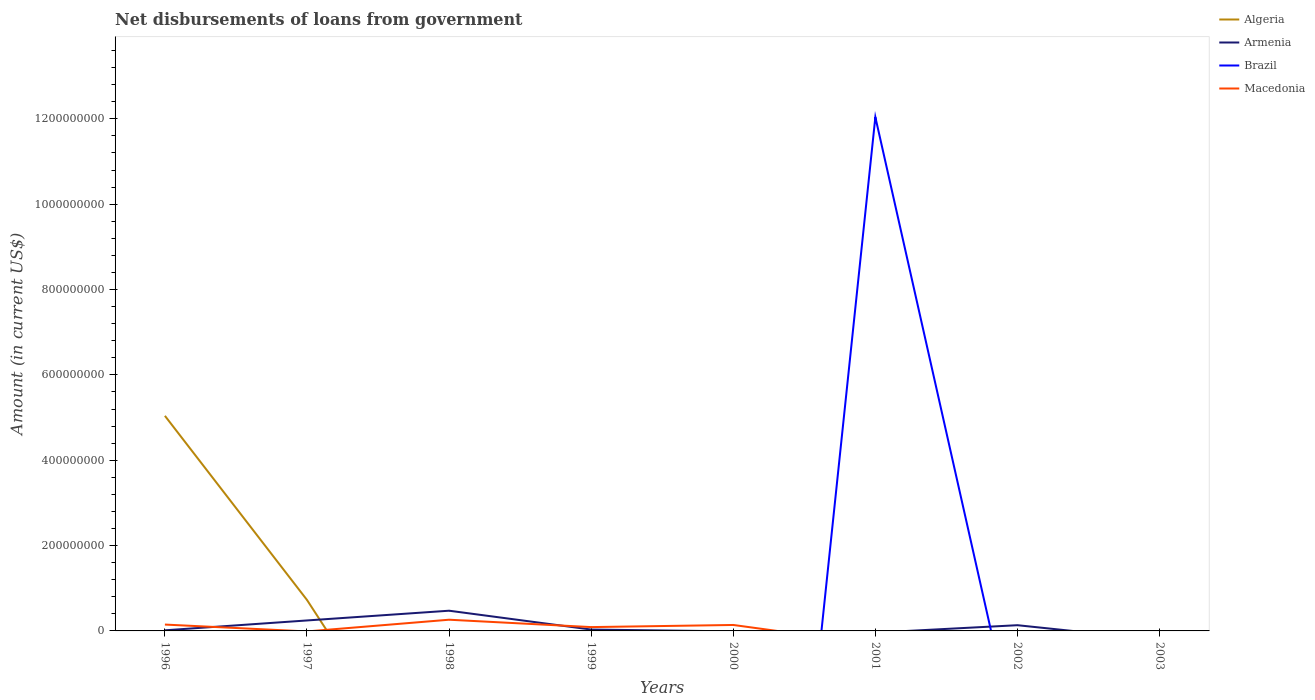How many different coloured lines are there?
Offer a terse response. 4. Does the line corresponding to Brazil intersect with the line corresponding to Macedonia?
Offer a terse response. Yes. Is the number of lines equal to the number of legend labels?
Offer a terse response. No. Across all years, what is the maximum amount of loan disbursed from government in Macedonia?
Provide a short and direct response. 0. What is the total amount of loan disbursed from government in Armenia in the graph?
Offer a very short reply. 1.11e+07. What is the difference between the highest and the second highest amount of loan disbursed from government in Armenia?
Provide a short and direct response. 4.74e+07. Is the amount of loan disbursed from government in Algeria strictly greater than the amount of loan disbursed from government in Macedonia over the years?
Offer a very short reply. No. How many lines are there?
Offer a terse response. 4. How many years are there in the graph?
Your answer should be compact. 8. Are the values on the major ticks of Y-axis written in scientific E-notation?
Provide a succinct answer. No. How many legend labels are there?
Your response must be concise. 4. How are the legend labels stacked?
Your response must be concise. Vertical. What is the title of the graph?
Provide a succinct answer. Net disbursements of loans from government. What is the label or title of the X-axis?
Give a very brief answer. Years. What is the Amount (in current US$) in Algeria in 1996?
Your answer should be very brief. 5.04e+08. What is the Amount (in current US$) in Armenia in 1996?
Your answer should be compact. 1.45e+06. What is the Amount (in current US$) of Macedonia in 1996?
Offer a terse response. 1.49e+07. What is the Amount (in current US$) in Algeria in 1997?
Your answer should be very brief. 7.26e+07. What is the Amount (in current US$) in Armenia in 1997?
Provide a short and direct response. 2.45e+07. What is the Amount (in current US$) in Macedonia in 1997?
Keep it short and to the point. 0. What is the Amount (in current US$) in Algeria in 1998?
Make the answer very short. 0. What is the Amount (in current US$) of Armenia in 1998?
Provide a succinct answer. 4.74e+07. What is the Amount (in current US$) in Macedonia in 1998?
Provide a short and direct response. 2.63e+07. What is the Amount (in current US$) of Armenia in 1999?
Offer a very short reply. 3.22e+06. What is the Amount (in current US$) of Brazil in 1999?
Your answer should be very brief. 0. What is the Amount (in current US$) in Macedonia in 1999?
Offer a terse response. 8.96e+06. What is the Amount (in current US$) of Algeria in 2000?
Your answer should be very brief. 0. What is the Amount (in current US$) in Macedonia in 2000?
Your answer should be compact. 1.40e+07. What is the Amount (in current US$) in Algeria in 2001?
Provide a short and direct response. 0. What is the Amount (in current US$) of Armenia in 2001?
Give a very brief answer. 0. What is the Amount (in current US$) in Brazil in 2001?
Your answer should be very brief. 1.20e+09. What is the Amount (in current US$) of Algeria in 2002?
Your answer should be very brief. 0. What is the Amount (in current US$) of Armenia in 2002?
Your response must be concise. 1.34e+07. What is the Amount (in current US$) in Macedonia in 2002?
Your response must be concise. 0. What is the Amount (in current US$) of Armenia in 2003?
Ensure brevity in your answer.  0. What is the Amount (in current US$) in Macedonia in 2003?
Your answer should be very brief. 0. Across all years, what is the maximum Amount (in current US$) in Algeria?
Offer a terse response. 5.04e+08. Across all years, what is the maximum Amount (in current US$) of Armenia?
Provide a short and direct response. 4.74e+07. Across all years, what is the maximum Amount (in current US$) of Brazil?
Your answer should be very brief. 1.20e+09. Across all years, what is the maximum Amount (in current US$) of Macedonia?
Offer a terse response. 2.63e+07. What is the total Amount (in current US$) of Algeria in the graph?
Offer a very short reply. 5.77e+08. What is the total Amount (in current US$) in Armenia in the graph?
Your answer should be compact. 8.99e+07. What is the total Amount (in current US$) of Brazil in the graph?
Your answer should be very brief. 1.20e+09. What is the total Amount (in current US$) in Macedonia in the graph?
Give a very brief answer. 6.41e+07. What is the difference between the Amount (in current US$) in Algeria in 1996 and that in 1997?
Offer a terse response. 4.31e+08. What is the difference between the Amount (in current US$) in Armenia in 1996 and that in 1997?
Give a very brief answer. -2.31e+07. What is the difference between the Amount (in current US$) of Armenia in 1996 and that in 1998?
Your response must be concise. -4.59e+07. What is the difference between the Amount (in current US$) in Macedonia in 1996 and that in 1998?
Keep it short and to the point. -1.14e+07. What is the difference between the Amount (in current US$) of Armenia in 1996 and that in 1999?
Make the answer very short. -1.77e+06. What is the difference between the Amount (in current US$) of Macedonia in 1996 and that in 1999?
Ensure brevity in your answer.  5.95e+06. What is the difference between the Amount (in current US$) in Macedonia in 1996 and that in 2000?
Offer a very short reply. 9.53e+05. What is the difference between the Amount (in current US$) in Armenia in 1996 and that in 2002?
Give a very brief answer. -1.19e+07. What is the difference between the Amount (in current US$) in Armenia in 1997 and that in 1998?
Provide a succinct answer. -2.28e+07. What is the difference between the Amount (in current US$) in Armenia in 1997 and that in 1999?
Your answer should be compact. 2.13e+07. What is the difference between the Amount (in current US$) in Armenia in 1997 and that in 2002?
Keep it short and to the point. 1.11e+07. What is the difference between the Amount (in current US$) of Armenia in 1998 and that in 1999?
Your response must be concise. 4.41e+07. What is the difference between the Amount (in current US$) in Macedonia in 1998 and that in 1999?
Your response must be concise. 1.73e+07. What is the difference between the Amount (in current US$) of Macedonia in 1998 and that in 2000?
Give a very brief answer. 1.23e+07. What is the difference between the Amount (in current US$) in Armenia in 1998 and that in 2002?
Provide a short and direct response. 3.40e+07. What is the difference between the Amount (in current US$) in Macedonia in 1999 and that in 2000?
Provide a short and direct response. -5.00e+06. What is the difference between the Amount (in current US$) in Armenia in 1999 and that in 2002?
Offer a terse response. -1.02e+07. What is the difference between the Amount (in current US$) of Algeria in 1996 and the Amount (in current US$) of Armenia in 1997?
Your answer should be very brief. 4.79e+08. What is the difference between the Amount (in current US$) in Algeria in 1996 and the Amount (in current US$) in Armenia in 1998?
Give a very brief answer. 4.57e+08. What is the difference between the Amount (in current US$) in Algeria in 1996 and the Amount (in current US$) in Macedonia in 1998?
Keep it short and to the point. 4.78e+08. What is the difference between the Amount (in current US$) of Armenia in 1996 and the Amount (in current US$) of Macedonia in 1998?
Provide a succinct answer. -2.48e+07. What is the difference between the Amount (in current US$) in Algeria in 1996 and the Amount (in current US$) in Armenia in 1999?
Offer a terse response. 5.01e+08. What is the difference between the Amount (in current US$) in Algeria in 1996 and the Amount (in current US$) in Macedonia in 1999?
Give a very brief answer. 4.95e+08. What is the difference between the Amount (in current US$) in Armenia in 1996 and the Amount (in current US$) in Macedonia in 1999?
Your response must be concise. -7.51e+06. What is the difference between the Amount (in current US$) in Algeria in 1996 and the Amount (in current US$) in Macedonia in 2000?
Keep it short and to the point. 4.90e+08. What is the difference between the Amount (in current US$) in Armenia in 1996 and the Amount (in current US$) in Macedonia in 2000?
Provide a short and direct response. -1.25e+07. What is the difference between the Amount (in current US$) of Algeria in 1996 and the Amount (in current US$) of Brazil in 2001?
Keep it short and to the point. -7.00e+08. What is the difference between the Amount (in current US$) in Armenia in 1996 and the Amount (in current US$) in Brazil in 2001?
Your answer should be very brief. -1.20e+09. What is the difference between the Amount (in current US$) of Algeria in 1996 and the Amount (in current US$) of Armenia in 2002?
Your response must be concise. 4.91e+08. What is the difference between the Amount (in current US$) in Algeria in 1997 and the Amount (in current US$) in Armenia in 1998?
Keep it short and to the point. 2.52e+07. What is the difference between the Amount (in current US$) in Algeria in 1997 and the Amount (in current US$) in Macedonia in 1998?
Your answer should be compact. 4.63e+07. What is the difference between the Amount (in current US$) of Armenia in 1997 and the Amount (in current US$) of Macedonia in 1998?
Your response must be concise. -1.74e+06. What is the difference between the Amount (in current US$) of Algeria in 1997 and the Amount (in current US$) of Armenia in 1999?
Ensure brevity in your answer.  6.94e+07. What is the difference between the Amount (in current US$) in Algeria in 1997 and the Amount (in current US$) in Macedonia in 1999?
Your answer should be compact. 6.36e+07. What is the difference between the Amount (in current US$) of Armenia in 1997 and the Amount (in current US$) of Macedonia in 1999?
Ensure brevity in your answer.  1.56e+07. What is the difference between the Amount (in current US$) in Algeria in 1997 and the Amount (in current US$) in Macedonia in 2000?
Keep it short and to the point. 5.86e+07. What is the difference between the Amount (in current US$) in Armenia in 1997 and the Amount (in current US$) in Macedonia in 2000?
Provide a succinct answer. 1.06e+07. What is the difference between the Amount (in current US$) in Algeria in 1997 and the Amount (in current US$) in Brazil in 2001?
Offer a very short reply. -1.13e+09. What is the difference between the Amount (in current US$) in Armenia in 1997 and the Amount (in current US$) in Brazil in 2001?
Your answer should be very brief. -1.18e+09. What is the difference between the Amount (in current US$) in Algeria in 1997 and the Amount (in current US$) in Armenia in 2002?
Give a very brief answer. 5.92e+07. What is the difference between the Amount (in current US$) in Armenia in 1998 and the Amount (in current US$) in Macedonia in 1999?
Ensure brevity in your answer.  3.84e+07. What is the difference between the Amount (in current US$) in Armenia in 1998 and the Amount (in current US$) in Macedonia in 2000?
Keep it short and to the point. 3.34e+07. What is the difference between the Amount (in current US$) in Armenia in 1998 and the Amount (in current US$) in Brazil in 2001?
Keep it short and to the point. -1.16e+09. What is the difference between the Amount (in current US$) of Armenia in 1999 and the Amount (in current US$) of Macedonia in 2000?
Your answer should be very brief. -1.07e+07. What is the difference between the Amount (in current US$) of Armenia in 1999 and the Amount (in current US$) of Brazil in 2001?
Keep it short and to the point. -1.20e+09. What is the average Amount (in current US$) in Algeria per year?
Offer a very short reply. 7.21e+07. What is the average Amount (in current US$) in Armenia per year?
Ensure brevity in your answer.  1.12e+07. What is the average Amount (in current US$) in Brazil per year?
Offer a very short reply. 1.51e+08. What is the average Amount (in current US$) of Macedonia per year?
Offer a terse response. 8.01e+06. In the year 1996, what is the difference between the Amount (in current US$) of Algeria and Amount (in current US$) of Armenia?
Your answer should be very brief. 5.03e+08. In the year 1996, what is the difference between the Amount (in current US$) in Algeria and Amount (in current US$) in Macedonia?
Give a very brief answer. 4.89e+08. In the year 1996, what is the difference between the Amount (in current US$) in Armenia and Amount (in current US$) in Macedonia?
Your answer should be very brief. -1.35e+07. In the year 1997, what is the difference between the Amount (in current US$) in Algeria and Amount (in current US$) in Armenia?
Provide a succinct answer. 4.81e+07. In the year 1998, what is the difference between the Amount (in current US$) in Armenia and Amount (in current US$) in Macedonia?
Make the answer very short. 2.11e+07. In the year 1999, what is the difference between the Amount (in current US$) in Armenia and Amount (in current US$) in Macedonia?
Ensure brevity in your answer.  -5.74e+06. What is the ratio of the Amount (in current US$) in Algeria in 1996 to that in 1997?
Your answer should be compact. 6.94. What is the ratio of the Amount (in current US$) of Armenia in 1996 to that in 1997?
Ensure brevity in your answer.  0.06. What is the ratio of the Amount (in current US$) in Armenia in 1996 to that in 1998?
Offer a very short reply. 0.03. What is the ratio of the Amount (in current US$) in Macedonia in 1996 to that in 1998?
Offer a very short reply. 0.57. What is the ratio of the Amount (in current US$) in Armenia in 1996 to that in 1999?
Make the answer very short. 0.45. What is the ratio of the Amount (in current US$) in Macedonia in 1996 to that in 1999?
Offer a very short reply. 1.66. What is the ratio of the Amount (in current US$) in Macedonia in 1996 to that in 2000?
Offer a very short reply. 1.07. What is the ratio of the Amount (in current US$) in Armenia in 1996 to that in 2002?
Your answer should be compact. 0.11. What is the ratio of the Amount (in current US$) of Armenia in 1997 to that in 1998?
Make the answer very short. 0.52. What is the ratio of the Amount (in current US$) of Armenia in 1997 to that in 1999?
Your answer should be very brief. 7.63. What is the ratio of the Amount (in current US$) of Armenia in 1997 to that in 2002?
Provide a succinct answer. 1.83. What is the ratio of the Amount (in current US$) in Armenia in 1998 to that in 1999?
Your answer should be very brief. 14.73. What is the ratio of the Amount (in current US$) in Macedonia in 1998 to that in 1999?
Ensure brevity in your answer.  2.93. What is the ratio of the Amount (in current US$) of Macedonia in 1998 to that in 2000?
Ensure brevity in your answer.  1.88. What is the ratio of the Amount (in current US$) in Armenia in 1998 to that in 2002?
Your answer should be very brief. 3.54. What is the ratio of the Amount (in current US$) in Macedonia in 1999 to that in 2000?
Give a very brief answer. 0.64. What is the ratio of the Amount (in current US$) in Armenia in 1999 to that in 2002?
Keep it short and to the point. 0.24. What is the difference between the highest and the second highest Amount (in current US$) in Armenia?
Ensure brevity in your answer.  2.28e+07. What is the difference between the highest and the second highest Amount (in current US$) in Macedonia?
Make the answer very short. 1.14e+07. What is the difference between the highest and the lowest Amount (in current US$) of Algeria?
Your response must be concise. 5.04e+08. What is the difference between the highest and the lowest Amount (in current US$) in Armenia?
Make the answer very short. 4.74e+07. What is the difference between the highest and the lowest Amount (in current US$) of Brazil?
Ensure brevity in your answer.  1.20e+09. What is the difference between the highest and the lowest Amount (in current US$) in Macedonia?
Your answer should be very brief. 2.63e+07. 